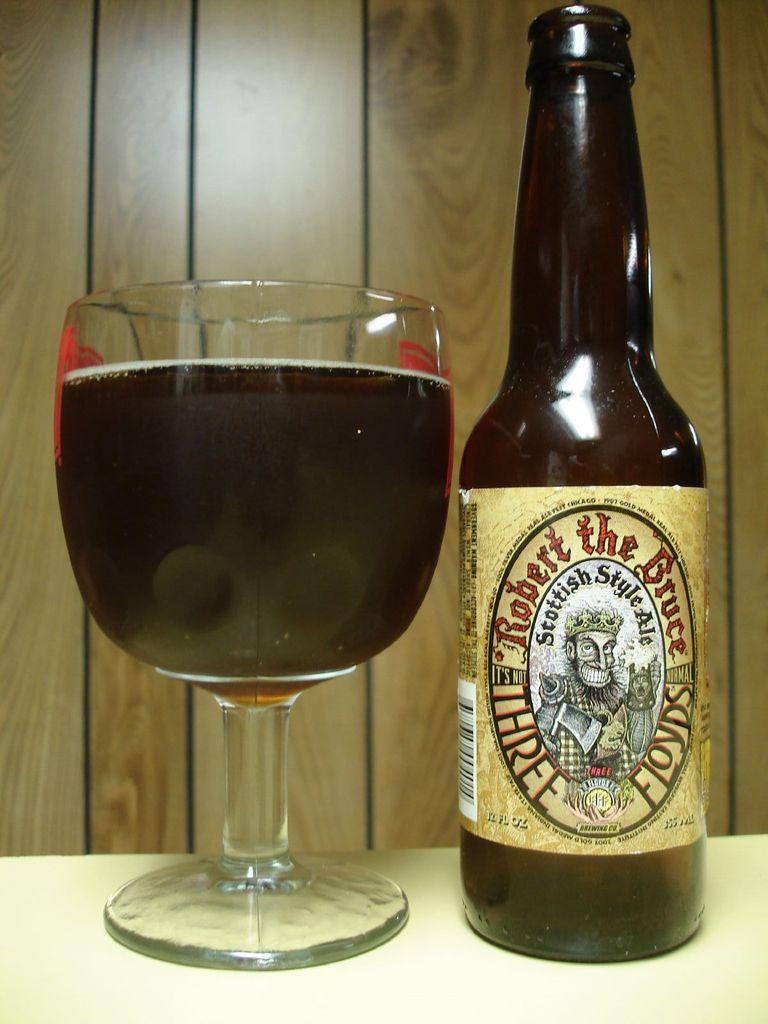What style ale is this?
Make the answer very short. Scottish. What brand is on the bottle?
Provide a short and direct response. Robert the bruce. 